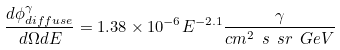<formula> <loc_0><loc_0><loc_500><loc_500>\frac { d \phi ^ { \gamma } _ { d i f f u s e } } { d \Omega d E } = 1 . 3 8 \times 1 0 ^ { - 6 } E ^ { - 2 . 1 } \frac { \gamma } { c m ^ { 2 } \ s \ s r \ G e V }</formula> 